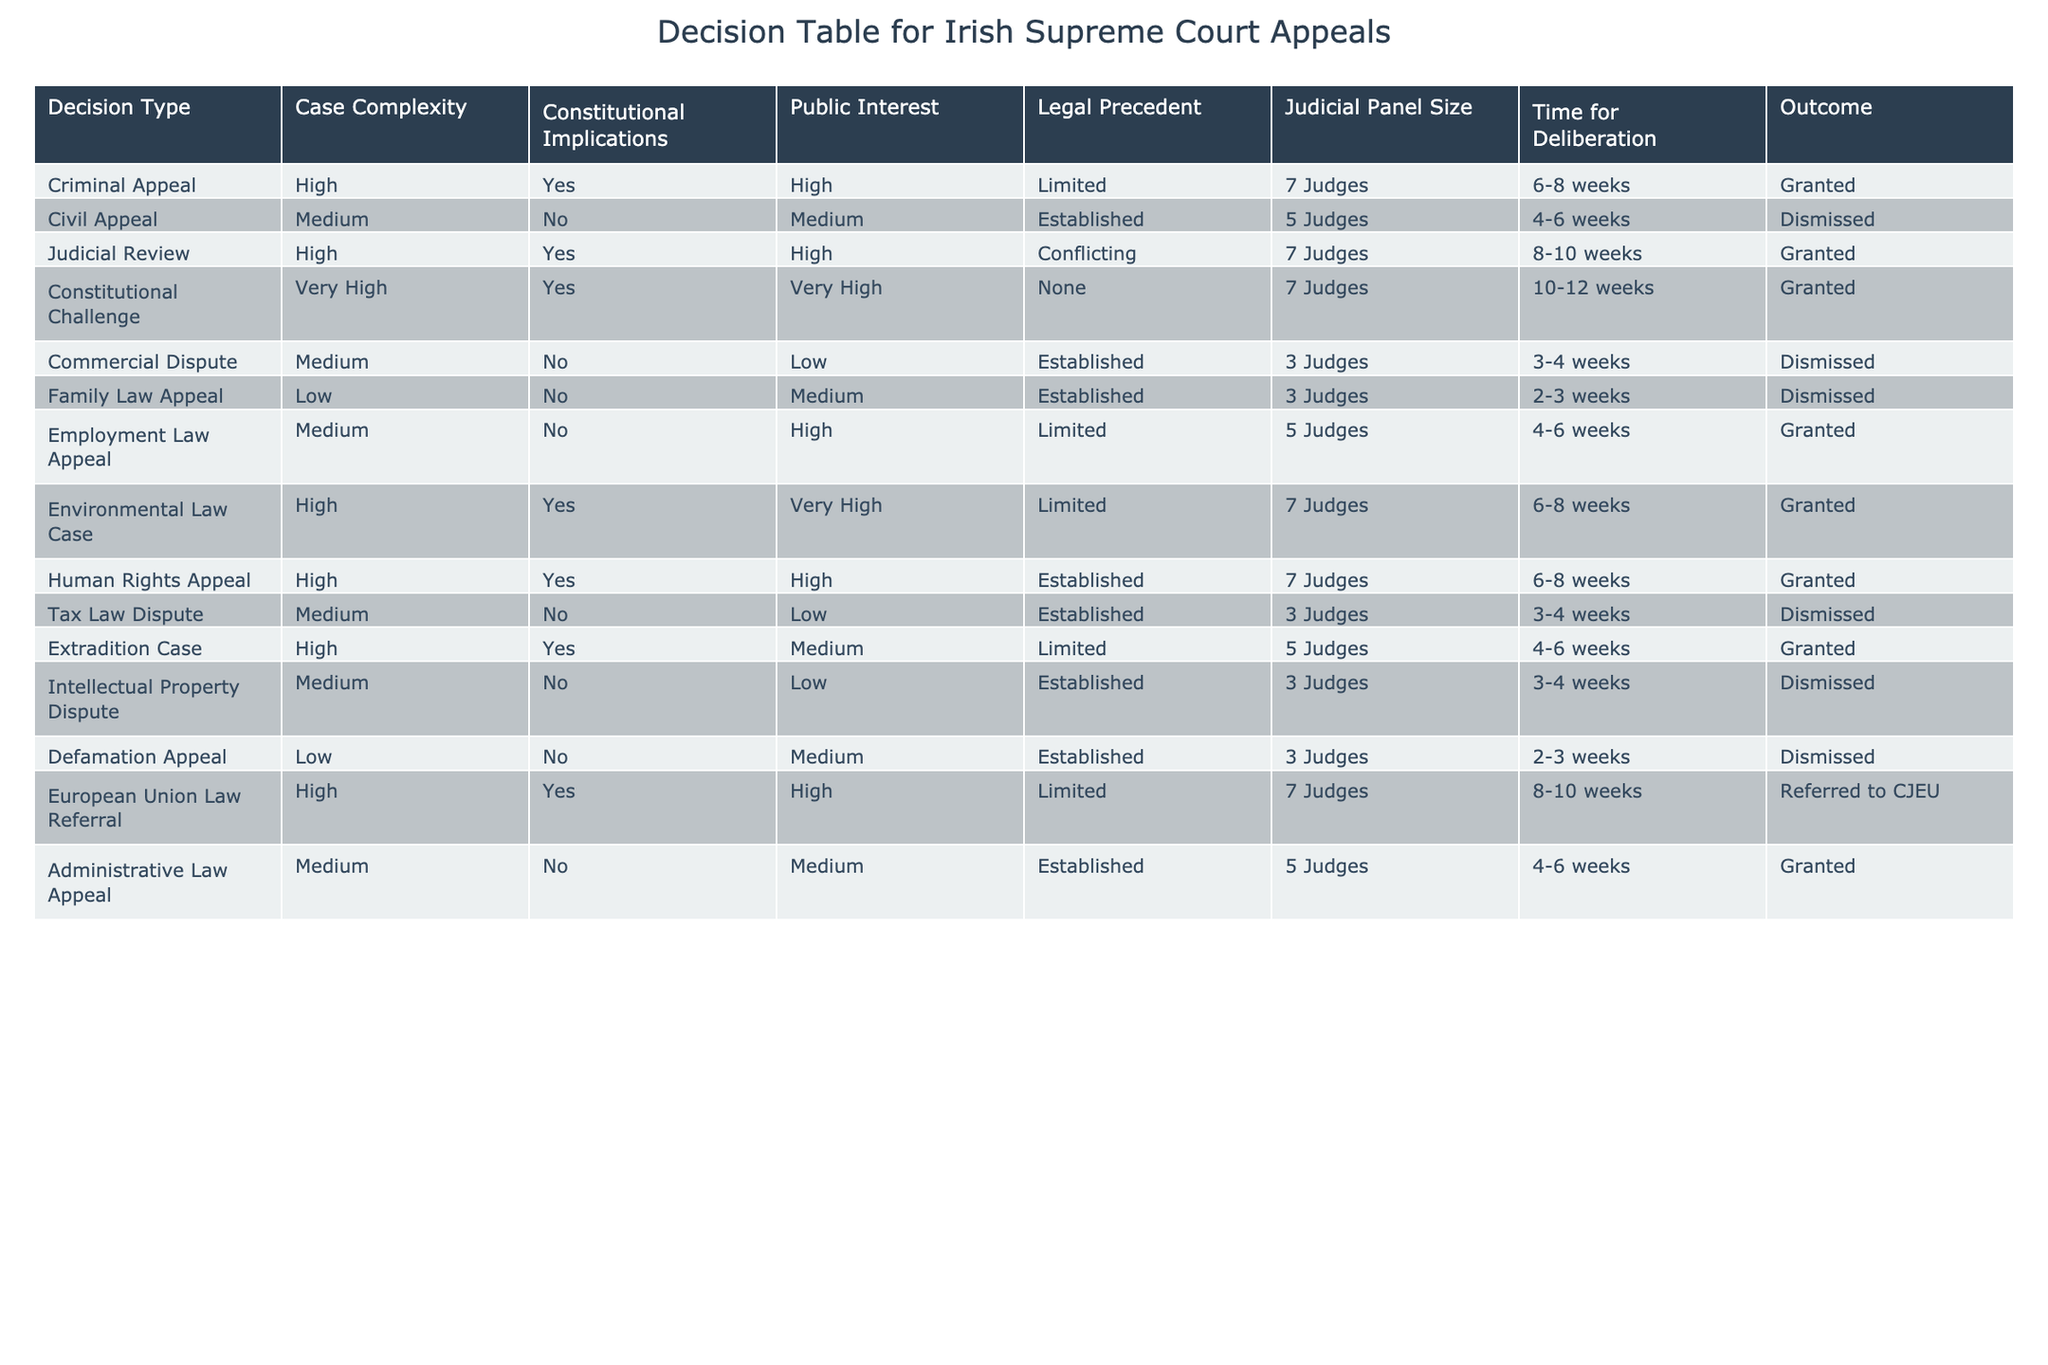What is the outcome of the Criminal Appeal? The table indicates that for a Criminal Appeal, the outcome is "Granted". This information is directly retrieved from the row that describes the Criminal Appeal case.
Answer: Granted How many judges are involved in the Constitutional Challenge? The row corresponding to the Constitutional Challenge shows that it involves 7 Judges. This is a specific fact that can be easily found in the table.
Answer: 7 Judges Which appeal type has the longest time for deliberation? Looking through the table, the Constitutional Challenge has a time for deliberation of 10-12 weeks, which is the longest when compared to other appeal types listed.
Answer: 10-12 weeks Is there any appeal type with both "High" public interest and "Very High" complexity? By analyzing the rows, we can see that the Constitutional Challenge fits this criterion; it has both "Very High" complexity and "Very High" public interest. Therefore, the answer is yes.
Answer: Yes What is the average time for deliberation for appeals with "Medium" case complexity? To calculate the average, we note the time for deliberation for Medium complexity appeals: Civil Appeal (4-6 weeks), Employment Law Appeal (4-6 weeks), Commercial Dispute (3-4 weeks), and Administrative Law Appeal (4-6 weeks). We can convert these ranges into easier numbers for averaging (considering midpoint values: 5 for 4-6 weeks, 3.5 for 3-4 weeks). Thus, the average = (5 + 5 + 3.5 + 5) / 4 = 4.625 weeks.
Answer: 4.625 weeks How many appeal types have "Limited" legal precedent? By scanning the table, we see that there are four appeal types with "Limited" legal precedent: Criminal Appeal, Employment Law Appeal, Extradition Case, and Environmental Law Case. Counting them gives us a total of 4 appeal types.
Answer: 4 appeal types What is the outcome of the appeal with the most public interest? The appeal type with the highest public interest is the Constitutional Challenge, which has an outcome of "Granted". We can identify this by checking the "Public Interest" column for the highest value.
Answer: Granted Which appeal type has the lowest case complexity with a public interest rating of "Medium"? Scanning through the table, the Family Law Appeal has a case complexity of "Low" and also a public interest of "Medium". Thus, it is the only one that meets these criteria.
Answer: Family Law Appeal Which case has the least number of judges involved, and what is the outcome? The case types with the least number of judges, as shown in the table, are the Commercial Dispute, Family Law Appeal, Tax Law Dispute, Intellectual Property Dispute, and all involve 3 judges. Checking their outcomes shows that all of them are "Dismissed".
Answer: Dismissed 